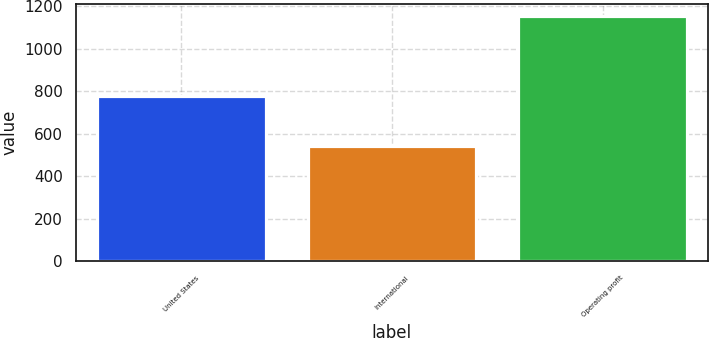Convert chart. <chart><loc_0><loc_0><loc_500><loc_500><bar_chart><fcel>United States<fcel>International<fcel>Operating profit<nl><fcel>777<fcel>542<fcel>1155<nl></chart> 